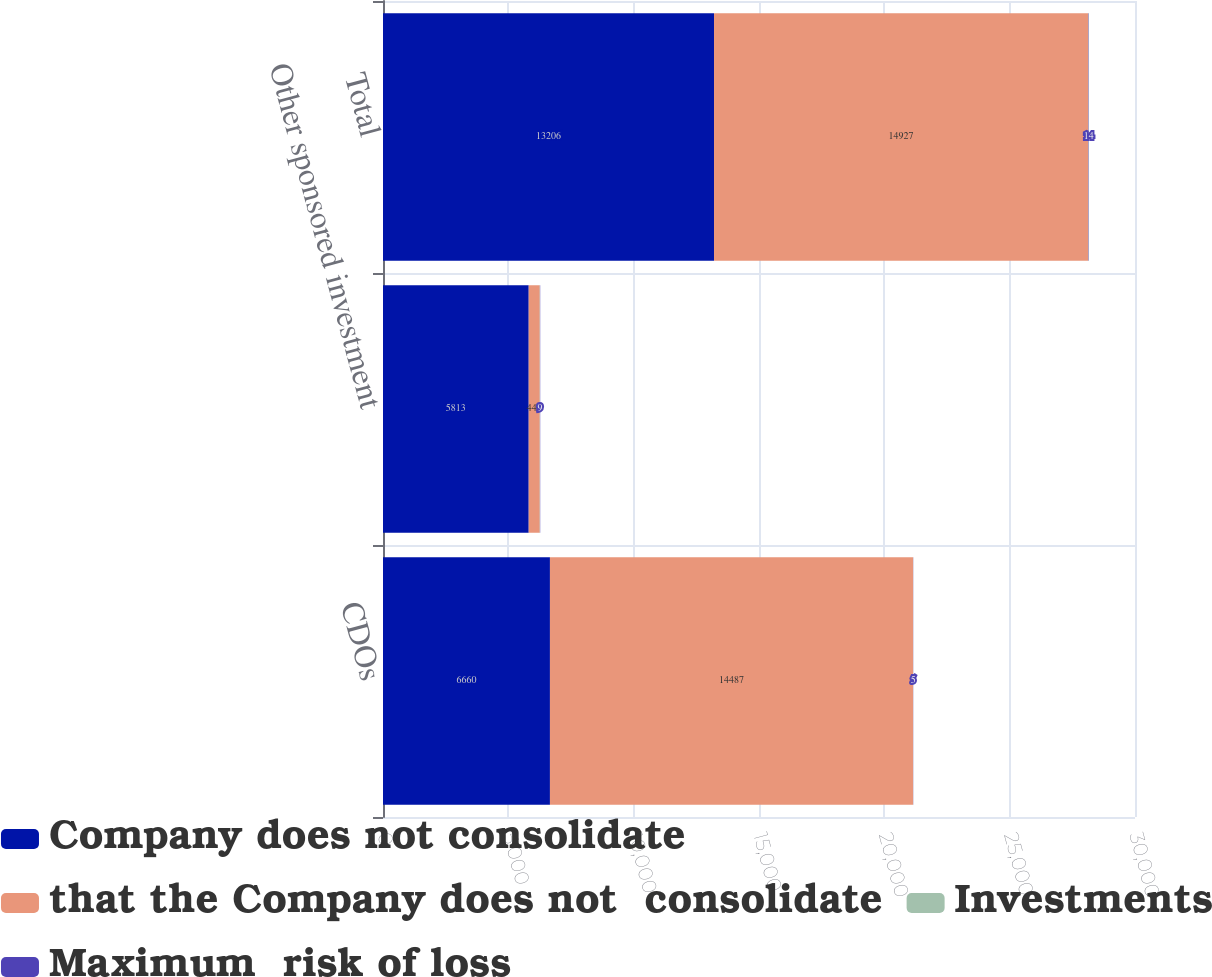Convert chart to OTSL. <chart><loc_0><loc_0><loc_500><loc_500><stacked_bar_chart><ecel><fcel>CDOs<fcel>Other sponsored investment<fcel>Total<nl><fcel>Company does not consolidate<fcel>6660<fcel>5813<fcel>13206<nl><fcel>that the Company does not  consolidate<fcel>14487<fcel>440<fcel>14927<nl><fcel>Investments<fcel>4<fcel>9<fcel>13<nl><fcel>Maximum  risk of loss<fcel>5<fcel>9<fcel>14<nl></chart> 